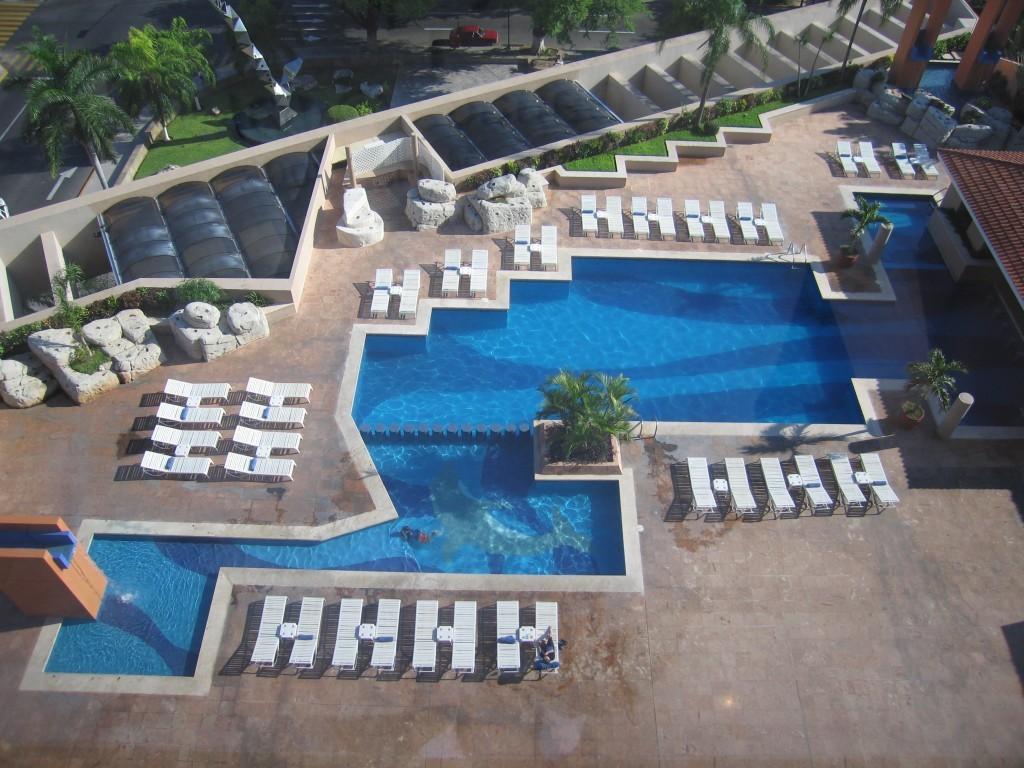Could you give a brief overview of what you see in this image? In this picture we can see a swimming pool, beside to the swimming pool we can find few chairs and plants, and also we can see a house, in the background we can find few trees and a car on the road. 